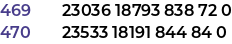Convert code to text. <code><loc_0><loc_0><loc_500><loc_500><_SML_>23036 18793 838 72 0
23533 18191 844 84 0</code> 